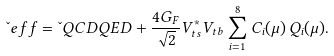Convert formula to latex. <formula><loc_0><loc_0><loc_500><loc_500>\L e f f = \L Q C D Q E D + \frac { 4 G _ { F } } { \sqrt { 2 } } V ^ { \ast } _ { t s } V _ { t b } \sum ^ { 8 } _ { i = 1 } C _ { i } ( \mu ) \, Q _ { i } ( \mu ) .</formula> 